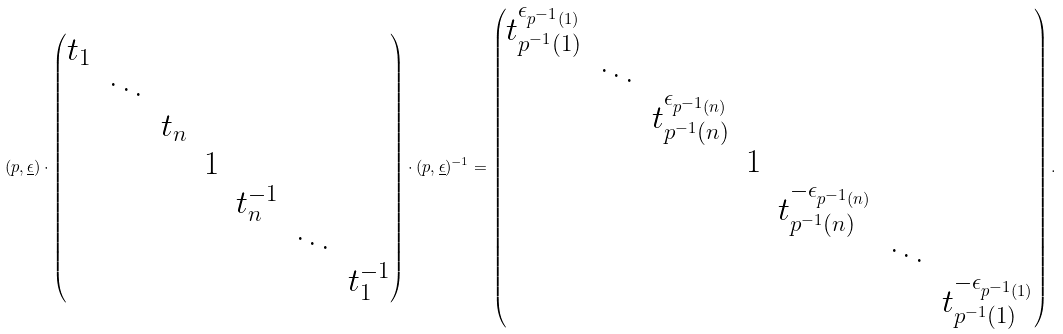<formula> <loc_0><loc_0><loc_500><loc_500>( p , \underline { \epsilon } ) \cdot \begin{pmatrix} t _ { 1 } & & & & & & \\ & \ddots & & & & & \\ & & t _ { n } & & & & \\ & & & 1 & & & \\ & & & & t _ { n } ^ { - 1 } & & \\ & & & & & \ddots & \\ & & & & & & t _ { 1 } ^ { - 1 } \end{pmatrix} \cdot ( p , \underline { \epsilon } ) ^ { - 1 } = \begin{pmatrix} t _ { p ^ { - 1 } ( 1 ) } ^ { \epsilon _ { p ^ { - 1 } ( 1 ) } } & & & & & & \\ & \ddots & & & & & \\ & & t _ { p ^ { - 1 } ( n ) } ^ { \epsilon _ { p ^ { - 1 } ( n ) } } & & & & \\ & & & 1 & & & \\ & & & & t _ { p ^ { - 1 } ( n ) } ^ { - \epsilon _ { p ^ { - 1 } ( n ) } } & & \\ & & & & & \ddots & \\ & & & & & & t _ { p ^ { - 1 } ( 1 ) } ^ { - \epsilon _ { p ^ { - 1 } ( 1 ) } } \end{pmatrix} .</formula> 